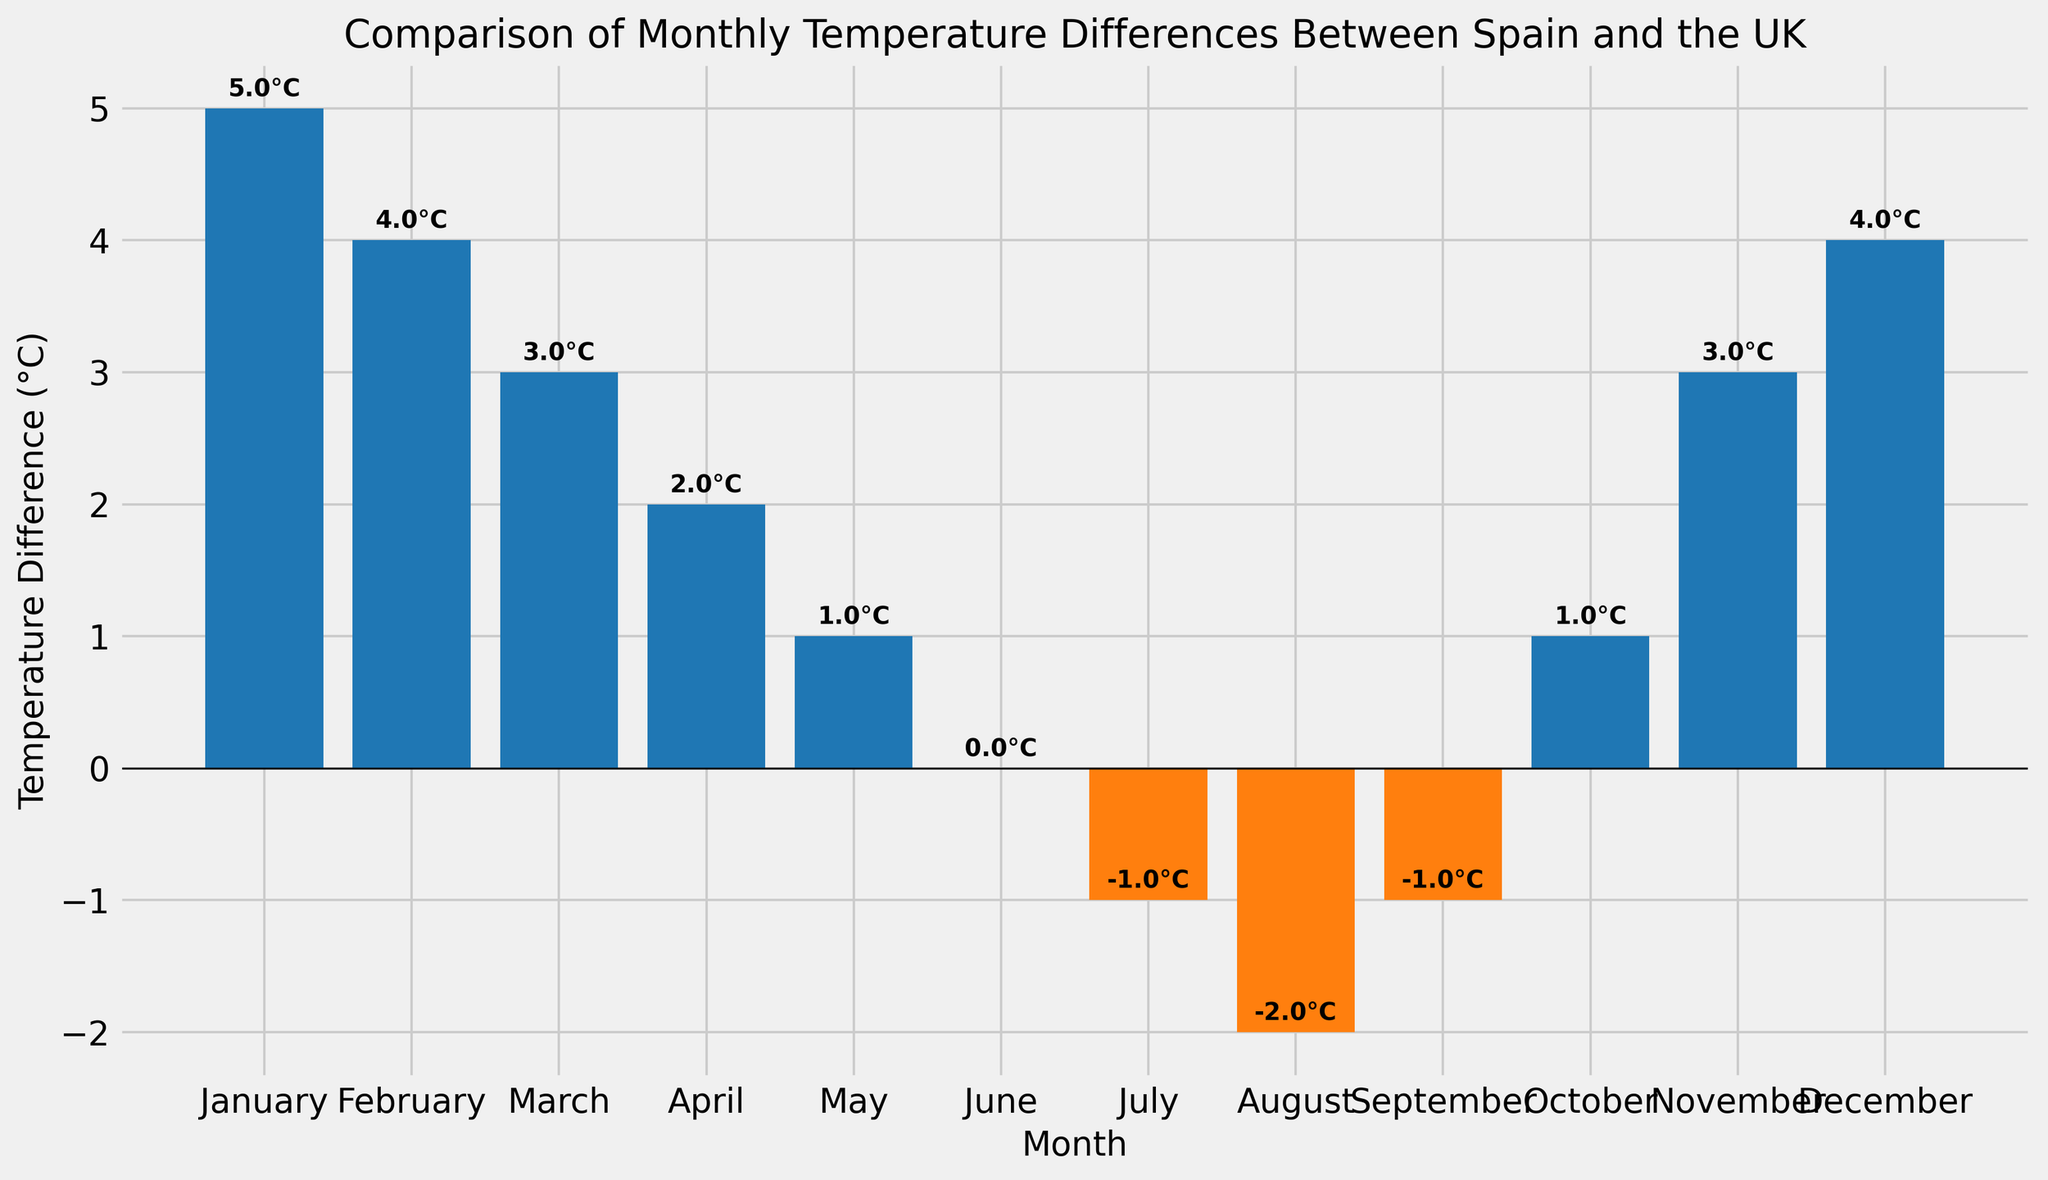Which month shows the highest temperature difference? The highest bar represents the month with the highest temperature difference. In the chart, the tallest blue bar corresponds to January.
Answer: January What is the lowest temperature difference observed in the year? The shortest orange bar represents the lowest temperature difference. In the chart, the shortest orange bar corresponds to August with -2°C.
Answer: -2°C How many months have a negative temperature difference? Count the months with orange bars, as these bars indicate negative temperature differences. There are three orange bars: July, August, and September.
Answer: 3 In which month does the temperature difference equal zero? Look for the bar that meets at the horizontal line (y = 0). The blue bar in June reaches exactly y = 0.
Answer: June What is the average temperature difference for the months January, February, and March? Add the temperature differences for January (5°C), February (4°C), and March (3°C) and then divide by 3. (5 + 4 + 3) / 3 = 4.
Answer: 4°C Is the temperature difference greater in April or October? Compare the heights of the blue bars for April and October. Both bars reach up to 2°C and 1°C, respectively. April has the greater temperature difference.
Answer: April What's the total temperature difference for the first half of the year (January to June)? Add the temperature differences from January to June: (5 + 4 + 3 + 2 + 1 + 0). The total is 15°C.
Answer: 15°C How much higher is the temperature difference in January compared to July? Subtract the temperature difference in July (-1°C) from January's (5°C): 5 - (-1) = 6.
Answer: 6°C Which month has the same temperature difference as November? Identify the month with the same bar height as November (3°C). March has a bar of the same height.
Answer: March By how much does the temperature difference change from May to June? Subtract June's temperature difference (0°C) from May's (1°C): 1 - 0 = 1.
Answer: 1°C 